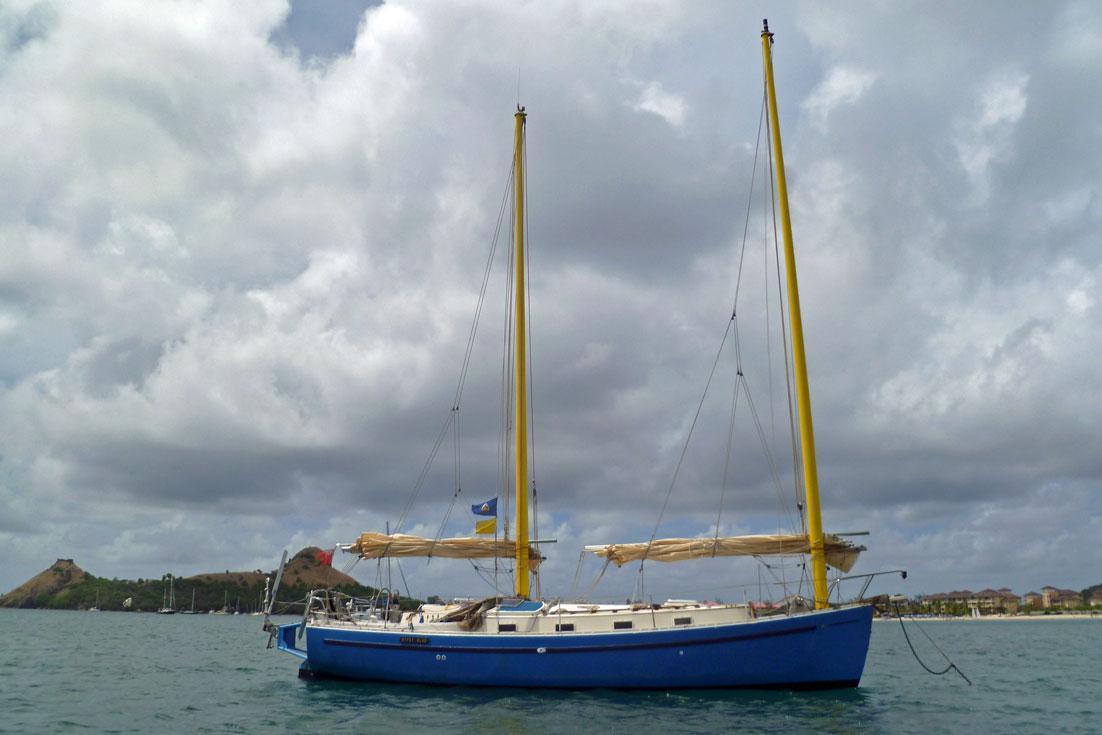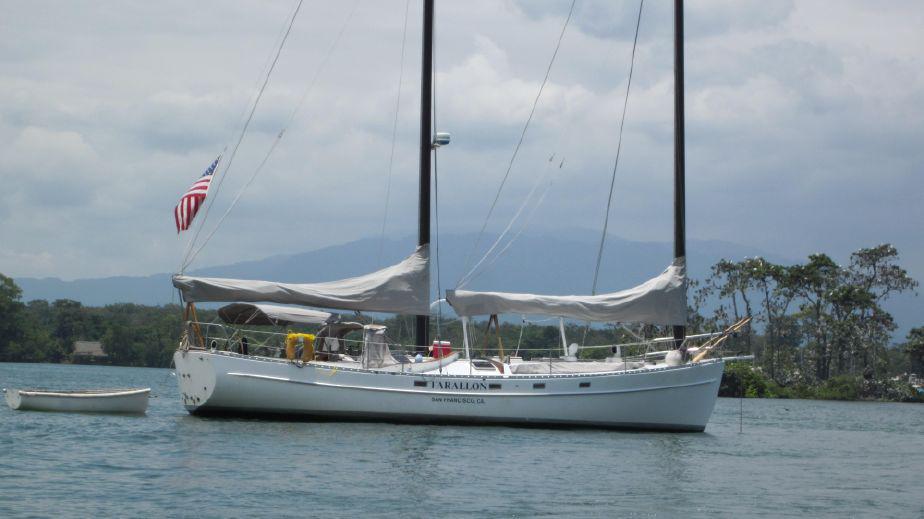The first image is the image on the left, the second image is the image on the right. Considering the images on both sides, is "The boat in the left image has a blue hull, and the boats in the left and right images have their sails in the same position [furled or unfurled]." valid? Answer yes or no. Yes. The first image is the image on the left, the second image is the image on the right. Given the left and right images, does the statement "The left and right image contains a total of three boats." hold true? Answer yes or no. Yes. 